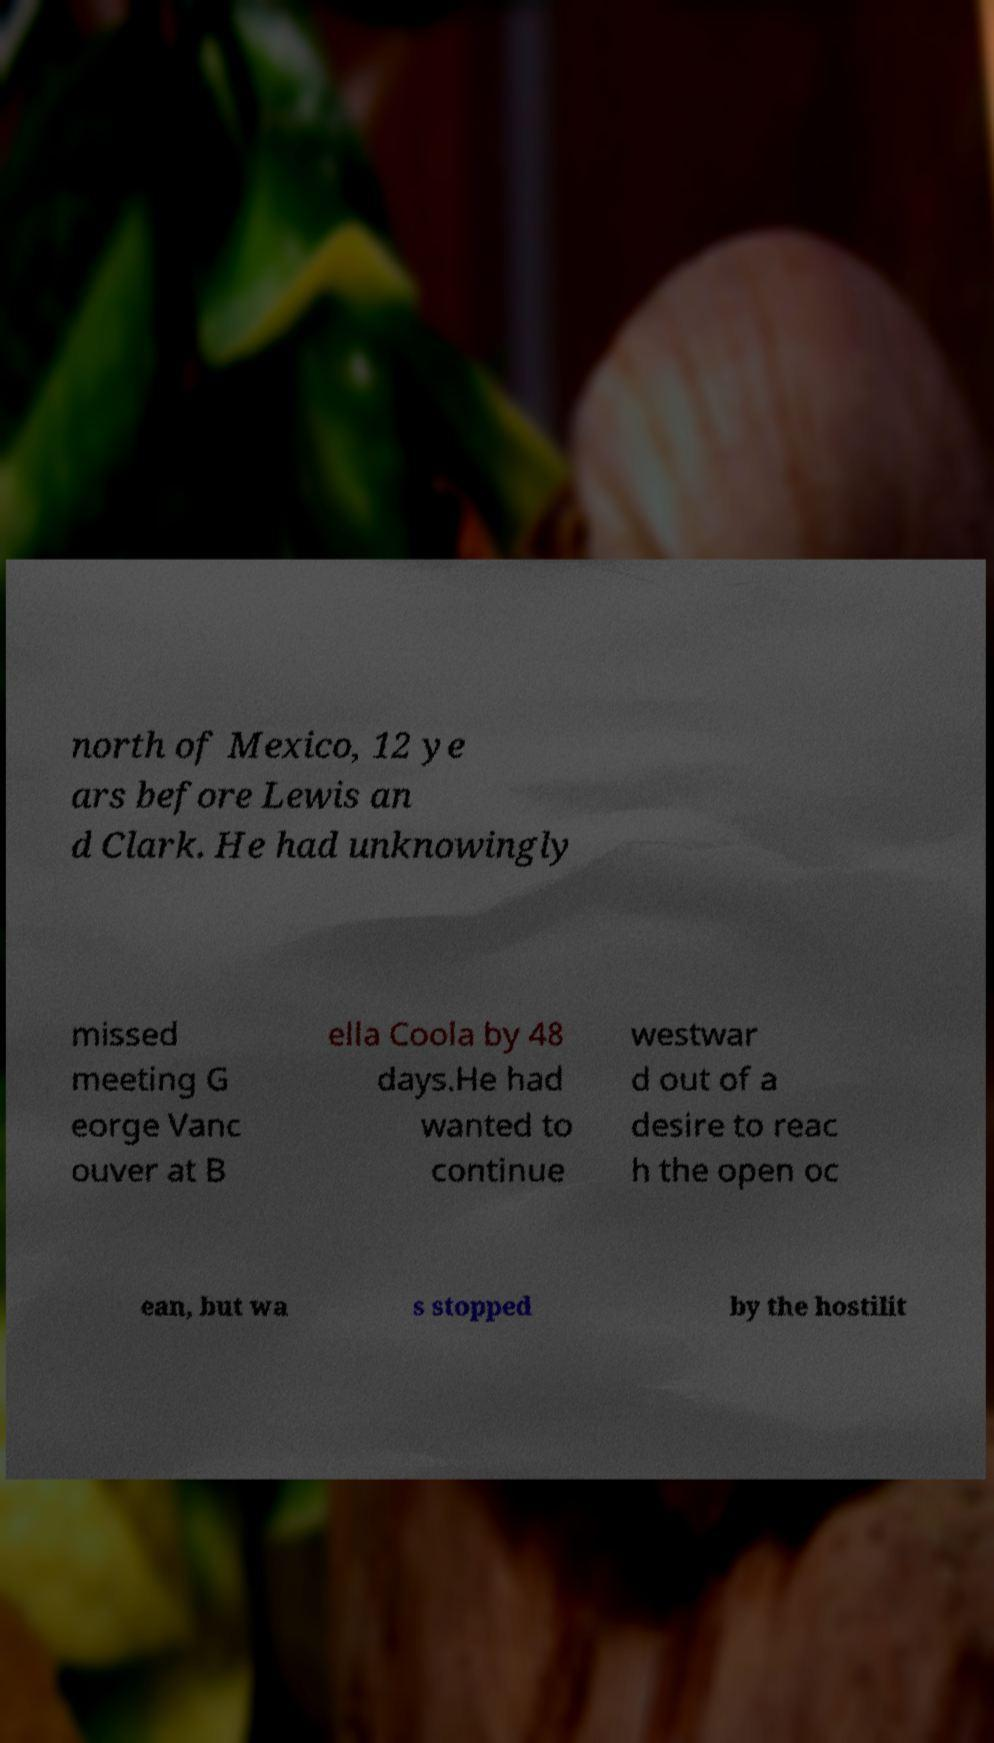There's text embedded in this image that I need extracted. Can you transcribe it verbatim? north of Mexico, 12 ye ars before Lewis an d Clark. He had unknowingly missed meeting G eorge Vanc ouver at B ella Coola by 48 days.He had wanted to continue westwar d out of a desire to reac h the open oc ean, but wa s stopped by the hostilit 